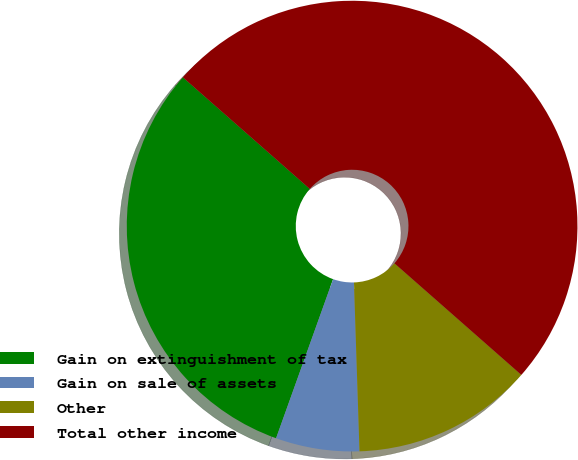Convert chart to OTSL. <chart><loc_0><loc_0><loc_500><loc_500><pie_chart><fcel>Gain on extinguishment of tax<fcel>Gain on sale of assets<fcel>Other<fcel>Total other income<nl><fcel>31.0%<fcel>6.0%<fcel>13.0%<fcel>50.0%<nl></chart> 